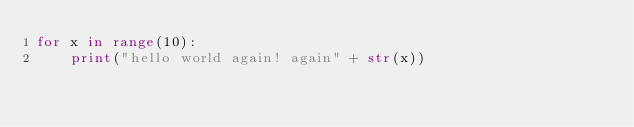Convert code to text. <code><loc_0><loc_0><loc_500><loc_500><_Python_>for x in range(10):
    print("hello world again! again" + str(x))
</code> 